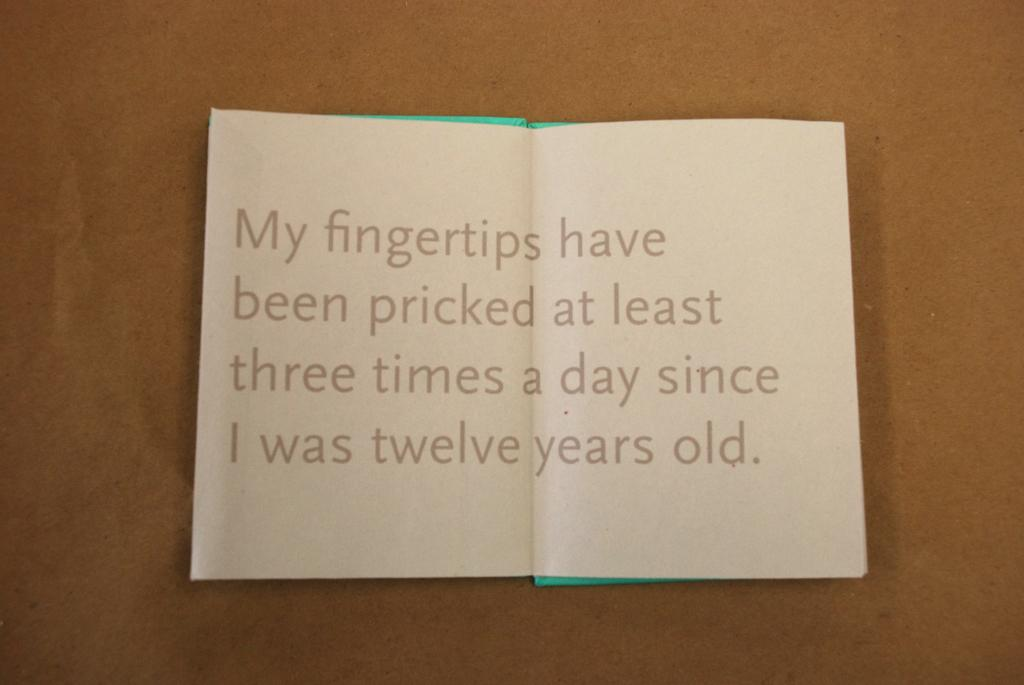<image>
Relay a brief, clear account of the picture shown. A sheet of paper stating that my fingertips have been pricked every day since they were twelve years old. 